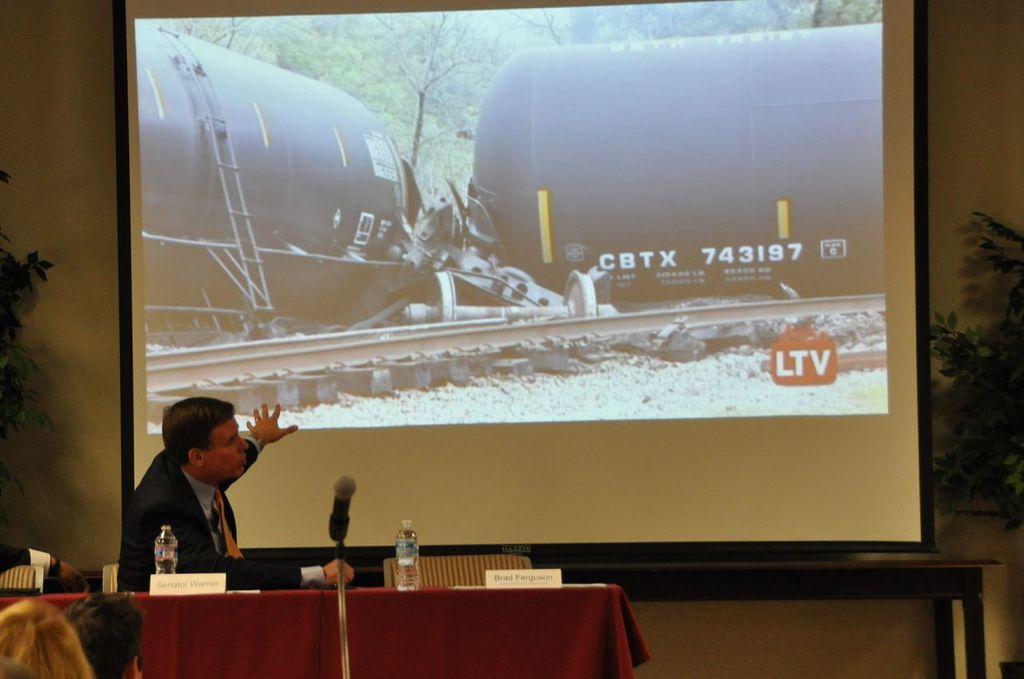What is the number on the side of the machine?
Offer a terse response. 743197. 